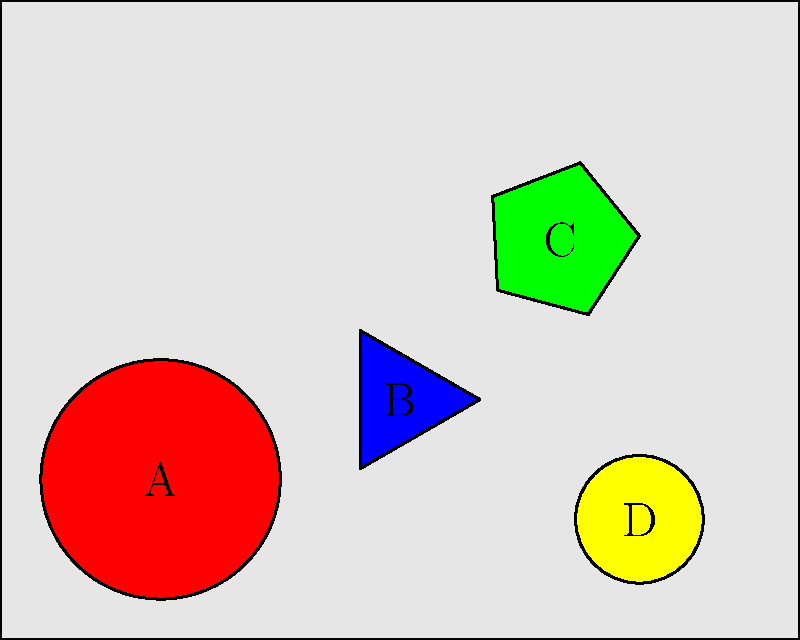You're packing your suitcase for a trip across multiple time zones. Given the arrangement of items A, B, C, and D in your suitcase as shown, which item should be removed to maximize the remaining space for additional items you might need in different climates? To determine which item to remove for maximizing remaining space, we need to consider the shape and position of each item:

1. Item A (red circle): Occupies a significant amount of space but its circular shape leaves gaps around it.
2. Item B (blue triangle): Takes up relatively little space and fits well in the corner.
3. Item C (green pentagon): Occupies a large area in the upper right corner and its shape doesn't conform well to the suitcase's edges.
4. Item D (yellow small circle): Takes up very little space and fits snugly in the bottom right corner.

Analyzing each option:
- Removing A would free up a good amount of space, but its circular shape means some space around it is already available.
- Removing B wouldn't provide much additional space and it's efficiently placed.
- Removing C would free up the most space, as it's the largest item and its awkward shape and position make it difficult to pack around.
- Removing D would provide very little additional space.

Therefore, removing item C (the green pentagon) would maximize the remaining space for additional items needed for various climates across different time zones.
Answer: C (green pentagon) 